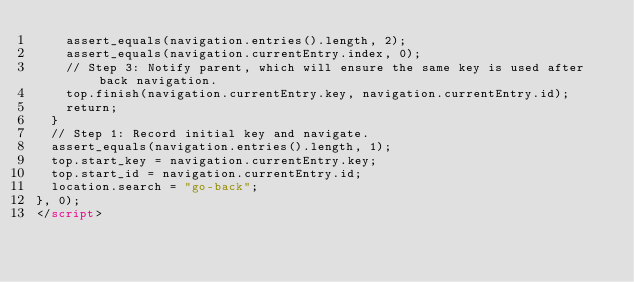Convert code to text. <code><loc_0><loc_0><loc_500><loc_500><_HTML_>    assert_equals(navigation.entries().length, 2);
    assert_equals(navigation.currentEntry.index, 0);
    // Step 3: Notify parent, which will ensure the same key is used after back navigation.
    top.finish(navigation.currentEntry.key, navigation.currentEntry.id);
    return;
  }
  // Step 1: Record initial key and navigate.
  assert_equals(navigation.entries().length, 1);
  top.start_key = navigation.currentEntry.key;
  top.start_id = navigation.currentEntry.id;
  location.search = "go-back";
}, 0);
</script>
</code> 